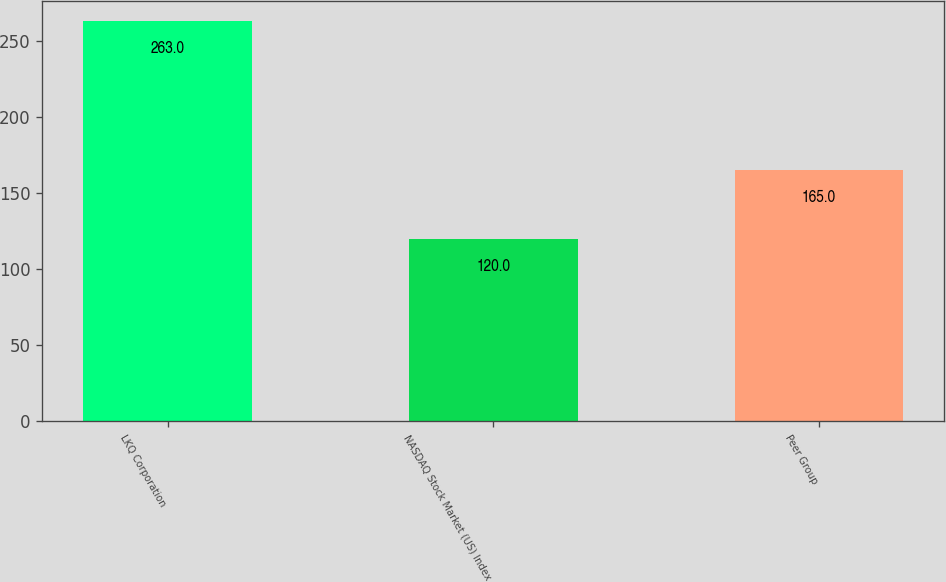Convert chart. <chart><loc_0><loc_0><loc_500><loc_500><bar_chart><fcel>LKQ Corporation<fcel>NASDAQ Stock Market (US) Index<fcel>Peer Group<nl><fcel>263<fcel>120<fcel>165<nl></chart> 